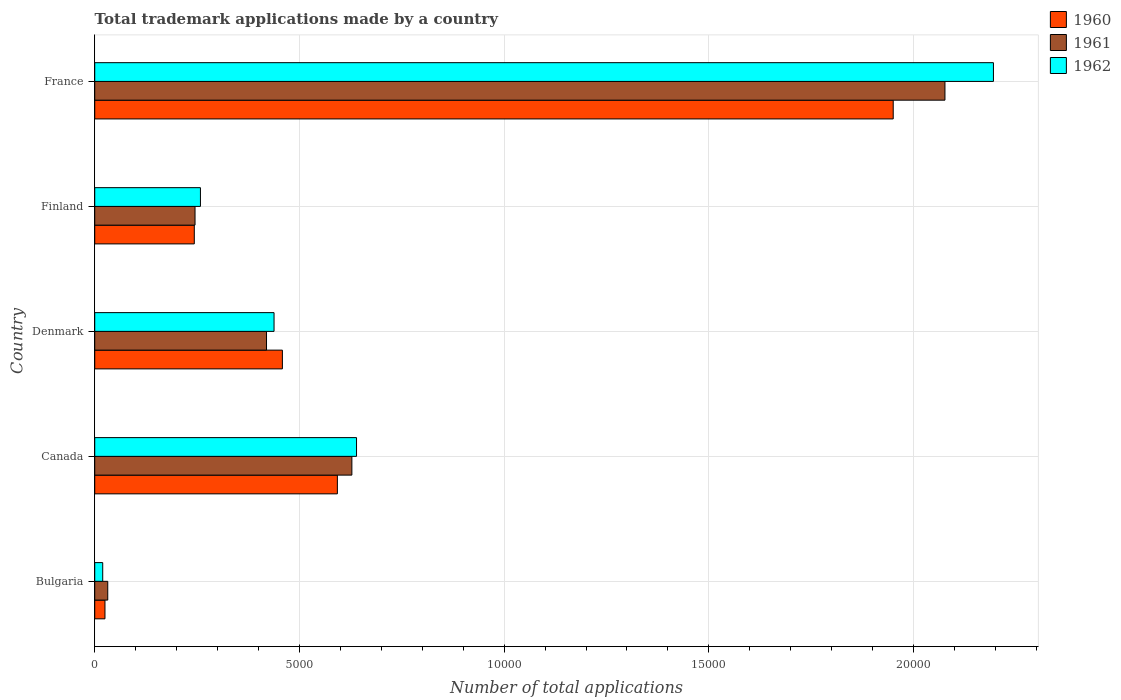How many different coloured bars are there?
Your answer should be very brief. 3. How many groups of bars are there?
Provide a short and direct response. 5. Are the number of bars per tick equal to the number of legend labels?
Provide a succinct answer. Yes. In how many cases, is the number of bars for a given country not equal to the number of legend labels?
Your answer should be compact. 0. What is the number of applications made by in 1961 in Bulgaria?
Your answer should be compact. 318. Across all countries, what is the maximum number of applications made by in 1962?
Your answer should be compact. 2.20e+04. Across all countries, what is the minimum number of applications made by in 1962?
Keep it short and to the point. 195. In which country was the number of applications made by in 1962 minimum?
Provide a succinct answer. Bulgaria. What is the total number of applications made by in 1961 in the graph?
Provide a short and direct response. 3.40e+04. What is the difference between the number of applications made by in 1962 in Denmark and that in Finland?
Provide a succinct answer. 1798. What is the difference between the number of applications made by in 1960 in Denmark and the number of applications made by in 1961 in Bulgaria?
Provide a short and direct response. 4266. What is the average number of applications made by in 1961 per country?
Make the answer very short. 6802.6. What is the difference between the number of applications made by in 1961 and number of applications made by in 1960 in France?
Your answer should be compact. 1264. In how many countries, is the number of applications made by in 1960 greater than 8000 ?
Offer a terse response. 1. What is the ratio of the number of applications made by in 1961 in Denmark to that in France?
Keep it short and to the point. 0.2. Is the difference between the number of applications made by in 1961 in Canada and France greater than the difference between the number of applications made by in 1960 in Canada and France?
Your response must be concise. No. What is the difference between the highest and the second highest number of applications made by in 1960?
Ensure brevity in your answer.  1.36e+04. What is the difference between the highest and the lowest number of applications made by in 1960?
Give a very brief answer. 1.93e+04. Is the sum of the number of applications made by in 1961 in Bulgaria and France greater than the maximum number of applications made by in 1962 across all countries?
Your response must be concise. No. What does the 2nd bar from the top in France represents?
Make the answer very short. 1961. How many bars are there?
Offer a very short reply. 15. What is the difference between two consecutive major ticks on the X-axis?
Provide a succinct answer. 5000. Are the values on the major ticks of X-axis written in scientific E-notation?
Offer a terse response. No. Does the graph contain grids?
Provide a succinct answer. Yes. How many legend labels are there?
Offer a terse response. 3. What is the title of the graph?
Your answer should be compact. Total trademark applications made by a country. Does "1996" appear as one of the legend labels in the graph?
Your answer should be compact. No. What is the label or title of the X-axis?
Ensure brevity in your answer.  Number of total applications. What is the label or title of the Y-axis?
Your answer should be very brief. Country. What is the Number of total applications of 1960 in Bulgaria?
Your answer should be compact. 250. What is the Number of total applications of 1961 in Bulgaria?
Provide a succinct answer. 318. What is the Number of total applications of 1962 in Bulgaria?
Your answer should be compact. 195. What is the Number of total applications of 1960 in Canada?
Give a very brief answer. 5927. What is the Number of total applications in 1961 in Canada?
Offer a terse response. 6281. What is the Number of total applications of 1962 in Canada?
Make the answer very short. 6395. What is the Number of total applications in 1960 in Denmark?
Offer a terse response. 4584. What is the Number of total applications in 1961 in Denmark?
Offer a very short reply. 4196. What is the Number of total applications of 1962 in Denmark?
Keep it short and to the point. 4380. What is the Number of total applications of 1960 in Finland?
Offer a terse response. 2432. What is the Number of total applications in 1961 in Finland?
Keep it short and to the point. 2450. What is the Number of total applications in 1962 in Finland?
Give a very brief answer. 2582. What is the Number of total applications in 1960 in France?
Offer a terse response. 1.95e+04. What is the Number of total applications of 1961 in France?
Provide a succinct answer. 2.08e+04. What is the Number of total applications in 1962 in France?
Give a very brief answer. 2.20e+04. Across all countries, what is the maximum Number of total applications of 1960?
Give a very brief answer. 1.95e+04. Across all countries, what is the maximum Number of total applications of 1961?
Give a very brief answer. 2.08e+04. Across all countries, what is the maximum Number of total applications of 1962?
Offer a very short reply. 2.20e+04. Across all countries, what is the minimum Number of total applications of 1960?
Provide a short and direct response. 250. Across all countries, what is the minimum Number of total applications of 1961?
Give a very brief answer. 318. Across all countries, what is the minimum Number of total applications in 1962?
Provide a short and direct response. 195. What is the total Number of total applications in 1960 in the graph?
Your answer should be very brief. 3.27e+04. What is the total Number of total applications of 1961 in the graph?
Provide a short and direct response. 3.40e+04. What is the total Number of total applications in 1962 in the graph?
Your answer should be very brief. 3.55e+04. What is the difference between the Number of total applications in 1960 in Bulgaria and that in Canada?
Make the answer very short. -5677. What is the difference between the Number of total applications in 1961 in Bulgaria and that in Canada?
Offer a very short reply. -5963. What is the difference between the Number of total applications in 1962 in Bulgaria and that in Canada?
Your response must be concise. -6200. What is the difference between the Number of total applications of 1960 in Bulgaria and that in Denmark?
Provide a short and direct response. -4334. What is the difference between the Number of total applications of 1961 in Bulgaria and that in Denmark?
Your answer should be compact. -3878. What is the difference between the Number of total applications of 1962 in Bulgaria and that in Denmark?
Make the answer very short. -4185. What is the difference between the Number of total applications in 1960 in Bulgaria and that in Finland?
Ensure brevity in your answer.  -2182. What is the difference between the Number of total applications in 1961 in Bulgaria and that in Finland?
Your answer should be very brief. -2132. What is the difference between the Number of total applications of 1962 in Bulgaria and that in Finland?
Ensure brevity in your answer.  -2387. What is the difference between the Number of total applications in 1960 in Bulgaria and that in France?
Ensure brevity in your answer.  -1.93e+04. What is the difference between the Number of total applications of 1961 in Bulgaria and that in France?
Provide a short and direct response. -2.04e+04. What is the difference between the Number of total applications in 1962 in Bulgaria and that in France?
Your answer should be compact. -2.18e+04. What is the difference between the Number of total applications in 1960 in Canada and that in Denmark?
Your response must be concise. 1343. What is the difference between the Number of total applications in 1961 in Canada and that in Denmark?
Make the answer very short. 2085. What is the difference between the Number of total applications in 1962 in Canada and that in Denmark?
Offer a terse response. 2015. What is the difference between the Number of total applications in 1960 in Canada and that in Finland?
Your response must be concise. 3495. What is the difference between the Number of total applications in 1961 in Canada and that in Finland?
Offer a terse response. 3831. What is the difference between the Number of total applications of 1962 in Canada and that in Finland?
Offer a very short reply. 3813. What is the difference between the Number of total applications of 1960 in Canada and that in France?
Provide a short and direct response. -1.36e+04. What is the difference between the Number of total applications in 1961 in Canada and that in France?
Your answer should be very brief. -1.45e+04. What is the difference between the Number of total applications in 1962 in Canada and that in France?
Make the answer very short. -1.56e+04. What is the difference between the Number of total applications of 1960 in Denmark and that in Finland?
Your response must be concise. 2152. What is the difference between the Number of total applications in 1961 in Denmark and that in Finland?
Your answer should be very brief. 1746. What is the difference between the Number of total applications of 1962 in Denmark and that in Finland?
Your answer should be very brief. 1798. What is the difference between the Number of total applications in 1960 in Denmark and that in France?
Make the answer very short. -1.49e+04. What is the difference between the Number of total applications of 1961 in Denmark and that in France?
Provide a succinct answer. -1.66e+04. What is the difference between the Number of total applications of 1962 in Denmark and that in France?
Keep it short and to the point. -1.76e+04. What is the difference between the Number of total applications of 1960 in Finland and that in France?
Your response must be concise. -1.71e+04. What is the difference between the Number of total applications of 1961 in Finland and that in France?
Your answer should be compact. -1.83e+04. What is the difference between the Number of total applications in 1962 in Finland and that in France?
Ensure brevity in your answer.  -1.94e+04. What is the difference between the Number of total applications of 1960 in Bulgaria and the Number of total applications of 1961 in Canada?
Provide a succinct answer. -6031. What is the difference between the Number of total applications in 1960 in Bulgaria and the Number of total applications in 1962 in Canada?
Ensure brevity in your answer.  -6145. What is the difference between the Number of total applications of 1961 in Bulgaria and the Number of total applications of 1962 in Canada?
Make the answer very short. -6077. What is the difference between the Number of total applications in 1960 in Bulgaria and the Number of total applications in 1961 in Denmark?
Keep it short and to the point. -3946. What is the difference between the Number of total applications of 1960 in Bulgaria and the Number of total applications of 1962 in Denmark?
Your answer should be very brief. -4130. What is the difference between the Number of total applications of 1961 in Bulgaria and the Number of total applications of 1962 in Denmark?
Your answer should be very brief. -4062. What is the difference between the Number of total applications of 1960 in Bulgaria and the Number of total applications of 1961 in Finland?
Provide a succinct answer. -2200. What is the difference between the Number of total applications in 1960 in Bulgaria and the Number of total applications in 1962 in Finland?
Your answer should be compact. -2332. What is the difference between the Number of total applications in 1961 in Bulgaria and the Number of total applications in 1962 in Finland?
Provide a short and direct response. -2264. What is the difference between the Number of total applications of 1960 in Bulgaria and the Number of total applications of 1961 in France?
Ensure brevity in your answer.  -2.05e+04. What is the difference between the Number of total applications in 1960 in Bulgaria and the Number of total applications in 1962 in France?
Ensure brevity in your answer.  -2.17e+04. What is the difference between the Number of total applications in 1961 in Bulgaria and the Number of total applications in 1962 in France?
Provide a succinct answer. -2.16e+04. What is the difference between the Number of total applications of 1960 in Canada and the Number of total applications of 1961 in Denmark?
Keep it short and to the point. 1731. What is the difference between the Number of total applications in 1960 in Canada and the Number of total applications in 1962 in Denmark?
Your answer should be very brief. 1547. What is the difference between the Number of total applications in 1961 in Canada and the Number of total applications in 1962 in Denmark?
Your answer should be compact. 1901. What is the difference between the Number of total applications in 1960 in Canada and the Number of total applications in 1961 in Finland?
Your answer should be very brief. 3477. What is the difference between the Number of total applications of 1960 in Canada and the Number of total applications of 1962 in Finland?
Provide a short and direct response. 3345. What is the difference between the Number of total applications of 1961 in Canada and the Number of total applications of 1962 in Finland?
Give a very brief answer. 3699. What is the difference between the Number of total applications in 1960 in Canada and the Number of total applications in 1961 in France?
Provide a succinct answer. -1.48e+04. What is the difference between the Number of total applications in 1960 in Canada and the Number of total applications in 1962 in France?
Your response must be concise. -1.60e+04. What is the difference between the Number of total applications in 1961 in Canada and the Number of total applications in 1962 in France?
Keep it short and to the point. -1.57e+04. What is the difference between the Number of total applications in 1960 in Denmark and the Number of total applications in 1961 in Finland?
Ensure brevity in your answer.  2134. What is the difference between the Number of total applications of 1960 in Denmark and the Number of total applications of 1962 in Finland?
Offer a terse response. 2002. What is the difference between the Number of total applications of 1961 in Denmark and the Number of total applications of 1962 in Finland?
Your answer should be very brief. 1614. What is the difference between the Number of total applications in 1960 in Denmark and the Number of total applications in 1961 in France?
Give a very brief answer. -1.62e+04. What is the difference between the Number of total applications of 1960 in Denmark and the Number of total applications of 1962 in France?
Give a very brief answer. -1.74e+04. What is the difference between the Number of total applications of 1961 in Denmark and the Number of total applications of 1962 in France?
Give a very brief answer. -1.78e+04. What is the difference between the Number of total applications of 1960 in Finland and the Number of total applications of 1961 in France?
Ensure brevity in your answer.  -1.83e+04. What is the difference between the Number of total applications in 1960 in Finland and the Number of total applications in 1962 in France?
Provide a succinct answer. -1.95e+04. What is the difference between the Number of total applications in 1961 in Finland and the Number of total applications in 1962 in France?
Offer a terse response. -1.95e+04. What is the average Number of total applications in 1960 per country?
Provide a succinct answer. 6539.4. What is the average Number of total applications in 1961 per country?
Offer a very short reply. 6802.6. What is the average Number of total applications in 1962 per country?
Offer a terse response. 7100.8. What is the difference between the Number of total applications of 1960 and Number of total applications of 1961 in Bulgaria?
Offer a very short reply. -68. What is the difference between the Number of total applications of 1960 and Number of total applications of 1962 in Bulgaria?
Your answer should be compact. 55. What is the difference between the Number of total applications in 1961 and Number of total applications in 1962 in Bulgaria?
Keep it short and to the point. 123. What is the difference between the Number of total applications in 1960 and Number of total applications in 1961 in Canada?
Offer a terse response. -354. What is the difference between the Number of total applications in 1960 and Number of total applications in 1962 in Canada?
Offer a very short reply. -468. What is the difference between the Number of total applications in 1961 and Number of total applications in 1962 in Canada?
Ensure brevity in your answer.  -114. What is the difference between the Number of total applications in 1960 and Number of total applications in 1961 in Denmark?
Offer a very short reply. 388. What is the difference between the Number of total applications of 1960 and Number of total applications of 1962 in Denmark?
Make the answer very short. 204. What is the difference between the Number of total applications in 1961 and Number of total applications in 1962 in Denmark?
Your answer should be compact. -184. What is the difference between the Number of total applications of 1960 and Number of total applications of 1962 in Finland?
Provide a succinct answer. -150. What is the difference between the Number of total applications in 1961 and Number of total applications in 1962 in Finland?
Keep it short and to the point. -132. What is the difference between the Number of total applications of 1960 and Number of total applications of 1961 in France?
Provide a short and direct response. -1264. What is the difference between the Number of total applications of 1960 and Number of total applications of 1962 in France?
Your answer should be very brief. -2448. What is the difference between the Number of total applications of 1961 and Number of total applications of 1962 in France?
Your response must be concise. -1184. What is the ratio of the Number of total applications in 1960 in Bulgaria to that in Canada?
Give a very brief answer. 0.04. What is the ratio of the Number of total applications in 1961 in Bulgaria to that in Canada?
Offer a terse response. 0.05. What is the ratio of the Number of total applications in 1962 in Bulgaria to that in Canada?
Keep it short and to the point. 0.03. What is the ratio of the Number of total applications of 1960 in Bulgaria to that in Denmark?
Your answer should be compact. 0.05. What is the ratio of the Number of total applications of 1961 in Bulgaria to that in Denmark?
Make the answer very short. 0.08. What is the ratio of the Number of total applications of 1962 in Bulgaria to that in Denmark?
Ensure brevity in your answer.  0.04. What is the ratio of the Number of total applications of 1960 in Bulgaria to that in Finland?
Ensure brevity in your answer.  0.1. What is the ratio of the Number of total applications of 1961 in Bulgaria to that in Finland?
Your response must be concise. 0.13. What is the ratio of the Number of total applications of 1962 in Bulgaria to that in Finland?
Offer a terse response. 0.08. What is the ratio of the Number of total applications in 1960 in Bulgaria to that in France?
Offer a terse response. 0.01. What is the ratio of the Number of total applications of 1961 in Bulgaria to that in France?
Give a very brief answer. 0.02. What is the ratio of the Number of total applications of 1962 in Bulgaria to that in France?
Provide a short and direct response. 0.01. What is the ratio of the Number of total applications of 1960 in Canada to that in Denmark?
Make the answer very short. 1.29. What is the ratio of the Number of total applications in 1961 in Canada to that in Denmark?
Make the answer very short. 1.5. What is the ratio of the Number of total applications in 1962 in Canada to that in Denmark?
Provide a short and direct response. 1.46. What is the ratio of the Number of total applications of 1960 in Canada to that in Finland?
Your answer should be compact. 2.44. What is the ratio of the Number of total applications of 1961 in Canada to that in Finland?
Make the answer very short. 2.56. What is the ratio of the Number of total applications in 1962 in Canada to that in Finland?
Offer a very short reply. 2.48. What is the ratio of the Number of total applications of 1960 in Canada to that in France?
Make the answer very short. 0.3. What is the ratio of the Number of total applications of 1961 in Canada to that in France?
Your response must be concise. 0.3. What is the ratio of the Number of total applications in 1962 in Canada to that in France?
Your response must be concise. 0.29. What is the ratio of the Number of total applications of 1960 in Denmark to that in Finland?
Your answer should be very brief. 1.88. What is the ratio of the Number of total applications of 1961 in Denmark to that in Finland?
Keep it short and to the point. 1.71. What is the ratio of the Number of total applications in 1962 in Denmark to that in Finland?
Offer a very short reply. 1.7. What is the ratio of the Number of total applications in 1960 in Denmark to that in France?
Your response must be concise. 0.23. What is the ratio of the Number of total applications of 1961 in Denmark to that in France?
Offer a terse response. 0.2. What is the ratio of the Number of total applications in 1962 in Denmark to that in France?
Provide a short and direct response. 0.2. What is the ratio of the Number of total applications in 1960 in Finland to that in France?
Keep it short and to the point. 0.12. What is the ratio of the Number of total applications of 1961 in Finland to that in France?
Keep it short and to the point. 0.12. What is the ratio of the Number of total applications of 1962 in Finland to that in France?
Give a very brief answer. 0.12. What is the difference between the highest and the second highest Number of total applications in 1960?
Your answer should be compact. 1.36e+04. What is the difference between the highest and the second highest Number of total applications of 1961?
Offer a very short reply. 1.45e+04. What is the difference between the highest and the second highest Number of total applications of 1962?
Offer a terse response. 1.56e+04. What is the difference between the highest and the lowest Number of total applications in 1960?
Offer a very short reply. 1.93e+04. What is the difference between the highest and the lowest Number of total applications of 1961?
Ensure brevity in your answer.  2.04e+04. What is the difference between the highest and the lowest Number of total applications of 1962?
Give a very brief answer. 2.18e+04. 